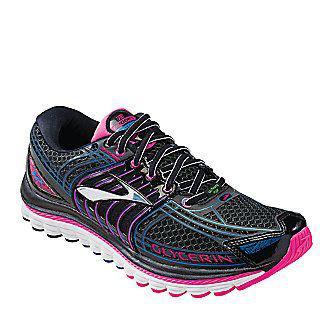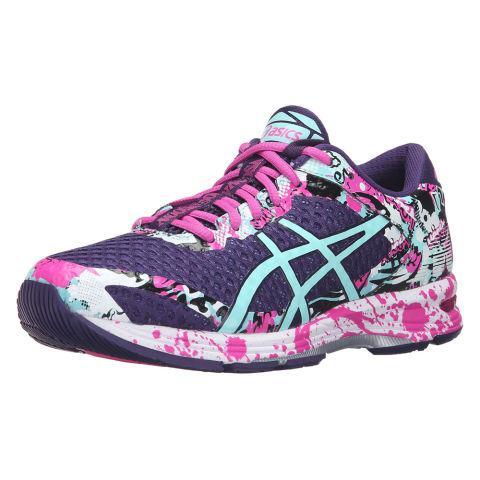The first image is the image on the left, the second image is the image on the right. Given the left and right images, does the statement "At least one shoe in the image on the right has pink laces." hold true? Answer yes or no. Yes. 